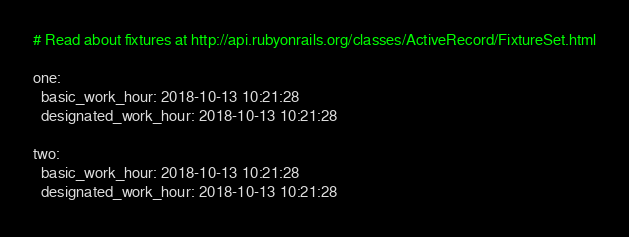Convert code to text. <code><loc_0><loc_0><loc_500><loc_500><_YAML_># Read about fixtures at http://api.rubyonrails.org/classes/ActiveRecord/FixtureSet.html

one:
  basic_work_hour: 2018-10-13 10:21:28
  designated_work_hour: 2018-10-13 10:21:28

two:
  basic_work_hour: 2018-10-13 10:21:28
  designated_work_hour: 2018-10-13 10:21:28
</code> 